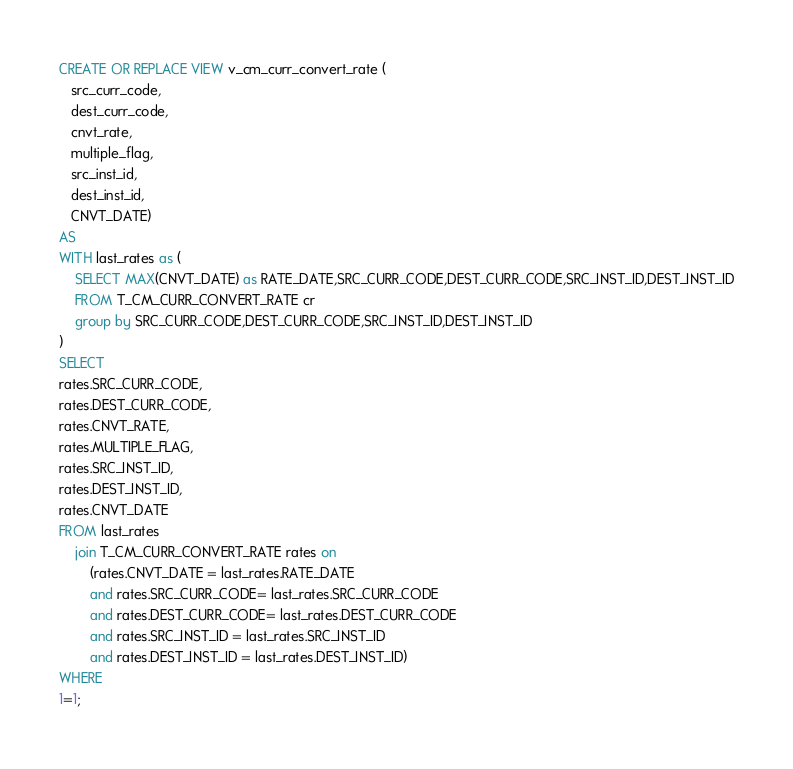Convert code to text. <code><loc_0><loc_0><loc_500><loc_500><_SQL_>CREATE OR REPLACE VIEW v_cm_curr_convert_rate (
   src_curr_code,
   dest_curr_code,
   cnvt_rate,
   multiple_flag,
   src_inst_id,
   dest_inst_id,
   CNVT_DATE)
AS
WITH last_rates as (
    SELECT MAX(CNVT_DATE) as RATE_DATE,SRC_CURR_CODE,DEST_CURR_CODE,SRC_INST_ID,DEST_INST_ID
    FROM T_CM_CURR_CONVERT_RATE cr
    group by SRC_CURR_CODE,DEST_CURR_CODE,SRC_INST_ID,DEST_INST_ID
)
SELECT
rates.SRC_CURR_CODE,
rates.DEST_CURR_CODE,
rates.CNVT_RATE,
rates.MULTIPLE_FLAG,
rates.SRC_INST_ID,
rates.DEST_INST_ID,
rates.CNVT_DATE
FROM last_rates
    join T_CM_CURR_CONVERT_RATE rates on
        (rates.CNVT_DATE = last_rates.RATE_DATE
        and rates.SRC_CURR_CODE= last_rates.SRC_CURR_CODE
        and rates.DEST_CURR_CODE= last_rates.DEST_CURR_CODE
        and rates.SRC_INST_ID = last_rates.SRC_INST_ID
        and rates.DEST_INST_ID = last_rates.DEST_INST_ID)
WHERE
1=1;
</code> 